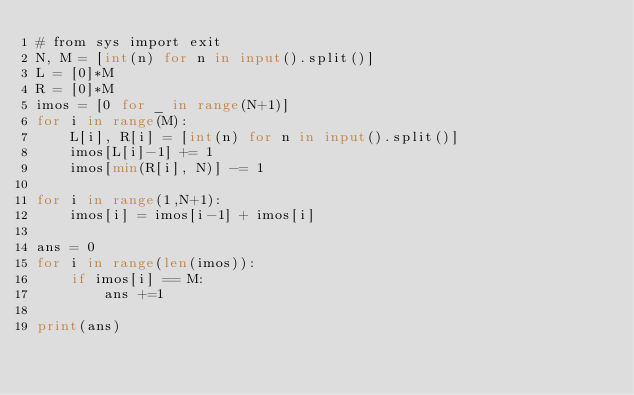Convert code to text. <code><loc_0><loc_0><loc_500><loc_500><_Python_># from sys import exit
N, M = [int(n) for n in input().split()]
L = [0]*M
R = [0]*M
imos = [0 for _ in range(N+1)]
for i in range(M):
    L[i], R[i] = [int(n) for n in input().split()]
    imos[L[i]-1] += 1
    imos[min(R[i], N)] -= 1

for i in range(1,N+1):
    imos[i] = imos[i-1] + imos[i]

ans = 0
for i in range(len(imos)):
    if imos[i] == M:
        ans +=1

print(ans)
</code> 